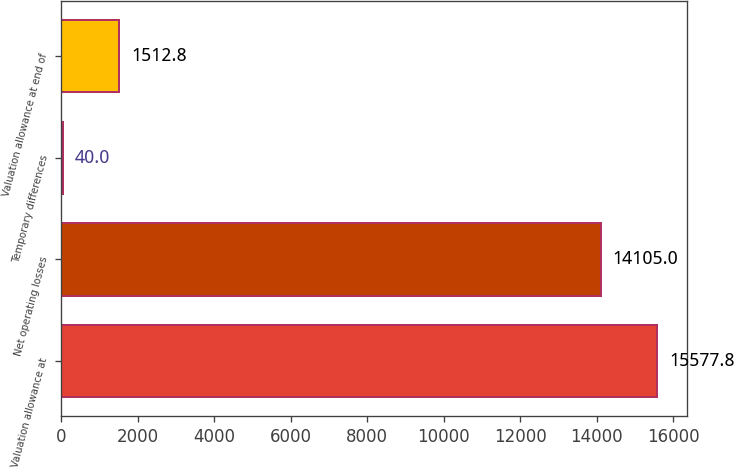Convert chart to OTSL. <chart><loc_0><loc_0><loc_500><loc_500><bar_chart><fcel>Valuation allowance at<fcel>Net operating losses<fcel>Temporary differences<fcel>Valuation allowance at end of<nl><fcel>15577.8<fcel>14105<fcel>40<fcel>1512.8<nl></chart> 